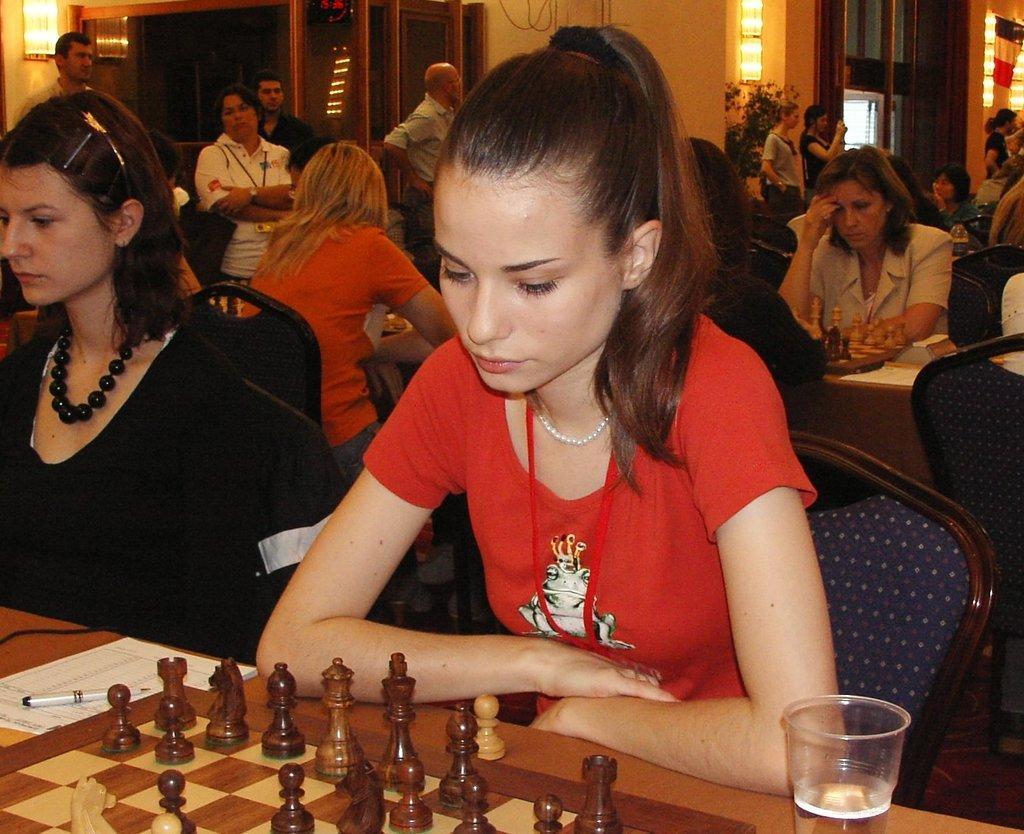Could you give a brief overview of what you see in this image? This is a picture taken in a chess competition. In the foreground of the picture there is a table and a chess board and a pen and paper. There are two women sitting in chairs. In the background there are windows, doors and lights. In the center of the image there are many people seated. On the right there are people standing. On the right of the foreground there is a glass. 